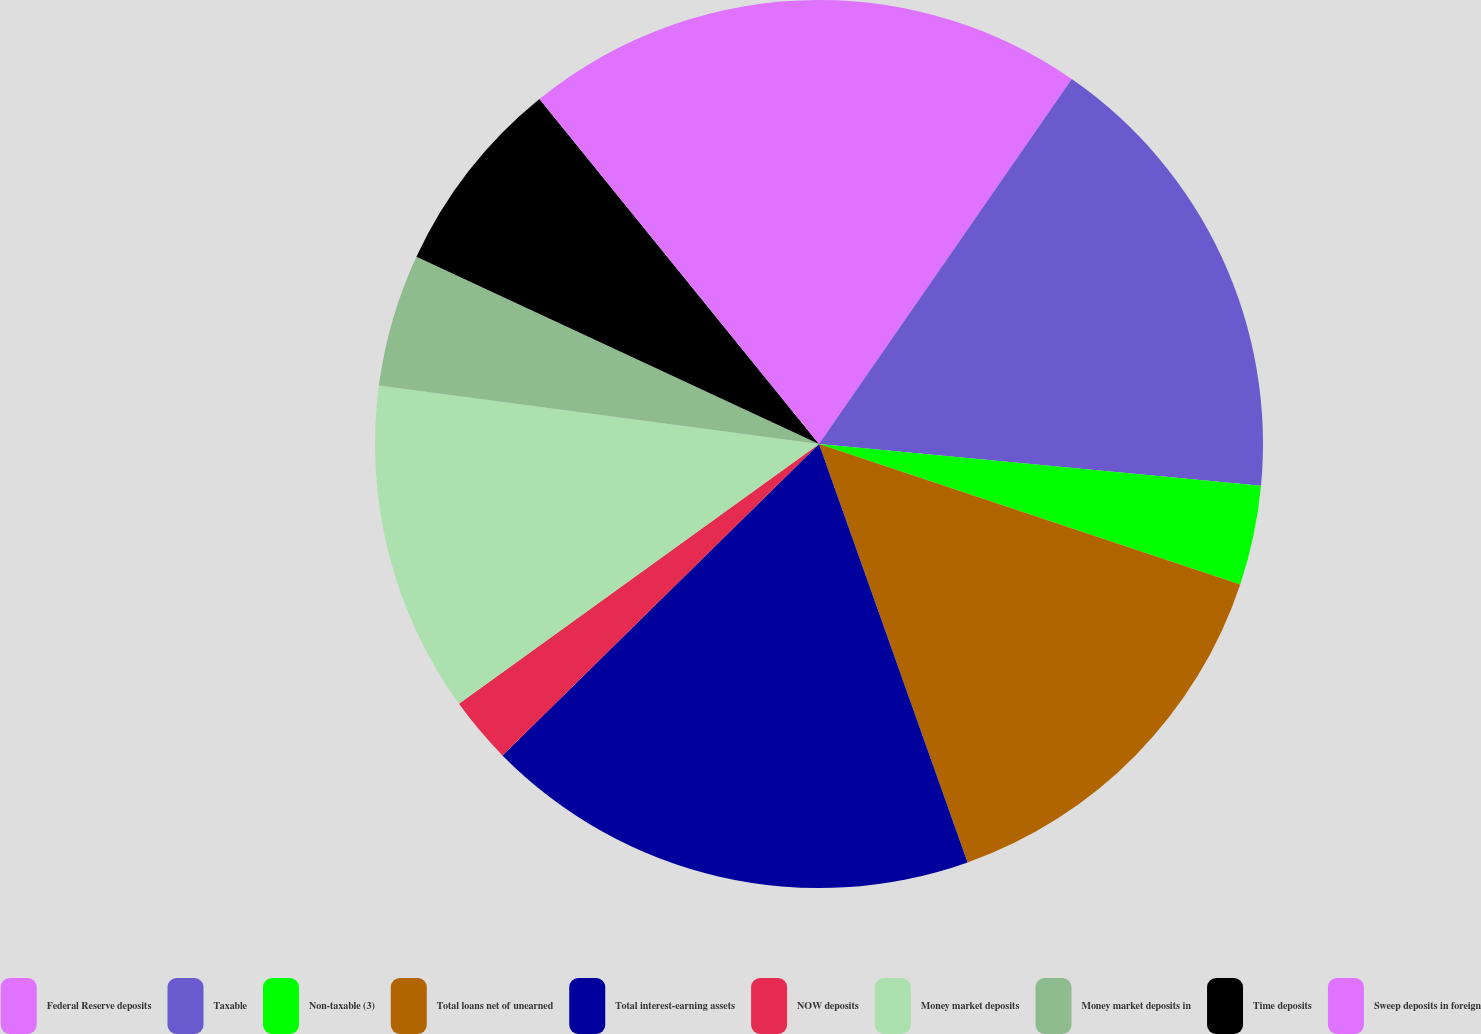Convert chart to OTSL. <chart><loc_0><loc_0><loc_500><loc_500><pie_chart><fcel>Federal Reserve deposits<fcel>Taxable<fcel>Non-taxable (3)<fcel>Total loans net of unearned<fcel>Total interest-earning assets<fcel>NOW deposits<fcel>Money market deposits<fcel>Money market deposits in<fcel>Time deposits<fcel>Sweep deposits in foreign<nl><fcel>9.64%<fcel>16.86%<fcel>3.62%<fcel>14.45%<fcel>18.06%<fcel>2.42%<fcel>12.05%<fcel>4.83%<fcel>7.23%<fcel>10.84%<nl></chart> 